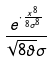Convert formula to latex. <formula><loc_0><loc_0><loc_500><loc_500>\frac { e ^ { \cdot \frac { x ^ { 8 } } { 8 \sigma ^ { 8 } } } } { \sqrt { 8 \vartheta } \sigma }</formula> 